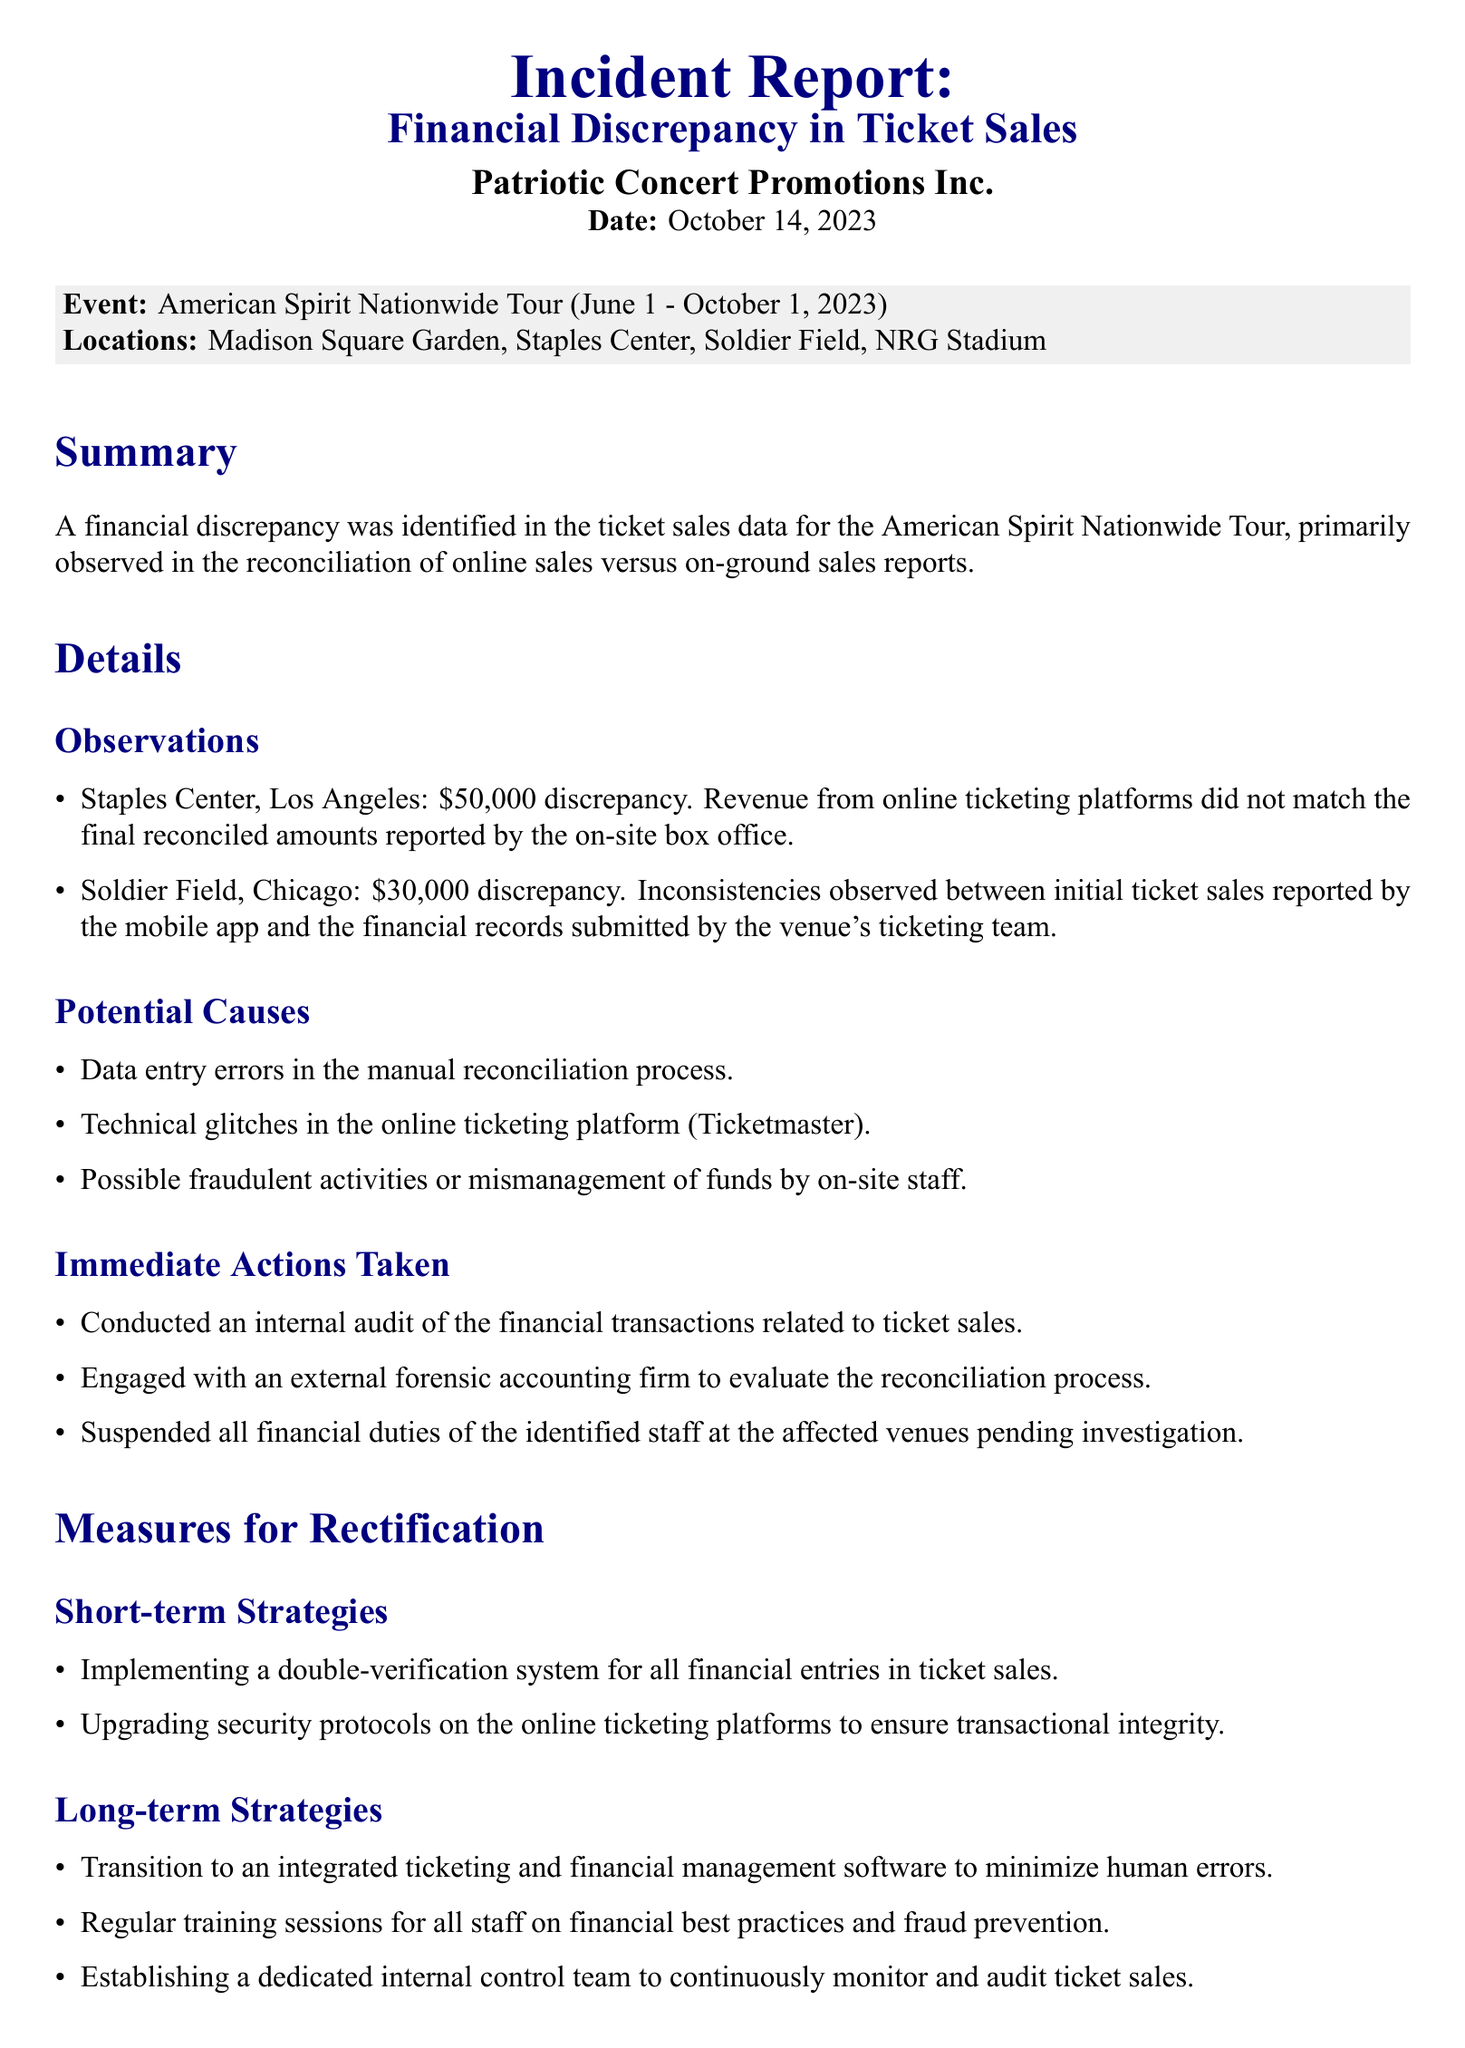What is the date of the incident report? The report is dated October 14, 2023.
Answer: October 14, 2023 What is the total discrepancy at Staples Center? The report states a discrepancy of $50,000 at Staples Center.
Answer: $50,000 Which online ticketing platform is mentioned? The platform referenced in the document is Ticketmaster.
Answer: Ticketmaster What is one immediate action taken? An internal audit of the financial transactions related to ticket sales was conducted.
Answer: Internal audit What is one long-term strategy for rectification? Transition to an integrated ticketing and financial management software is proposed.
Answer: Integrated software What are the two affected venues mentioned? The venues with discrepancies are Staples Center and Soldier Field.
Answer: Staples Center, Soldier Field How much was the discrepancy at Soldier Field? The document indicates a discrepancy of $30,000 at Soldier Field.
Answer: $30,000 What kind of firm was engaged for evaluation? An external forensic accounting firm was engaged.
Answer: Forensic accounting firm 